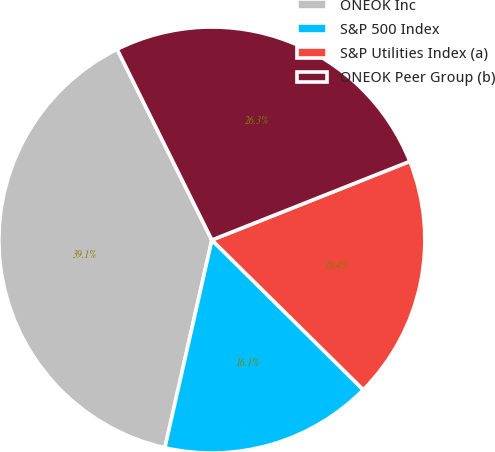<chart> <loc_0><loc_0><loc_500><loc_500><pie_chart><fcel>ONEOK Inc<fcel>S&P 500 Index<fcel>S&P Utilities Index (a)<fcel>ONEOK Peer Group (b)<nl><fcel>39.12%<fcel>16.13%<fcel>18.43%<fcel>26.32%<nl></chart> 